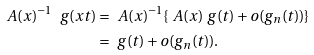Convert formula to latex. <formula><loc_0><loc_0><loc_500><loc_500>\ A ( x ) ^ { - 1 } \ g ( x t ) & = \ A ( x ) ^ { - 1 } \{ \ A ( x ) \ g ( t ) + o ( g _ { n } ( t ) ) \} \\ & = \ g ( t ) + o ( g _ { n } ( t ) ) .</formula> 